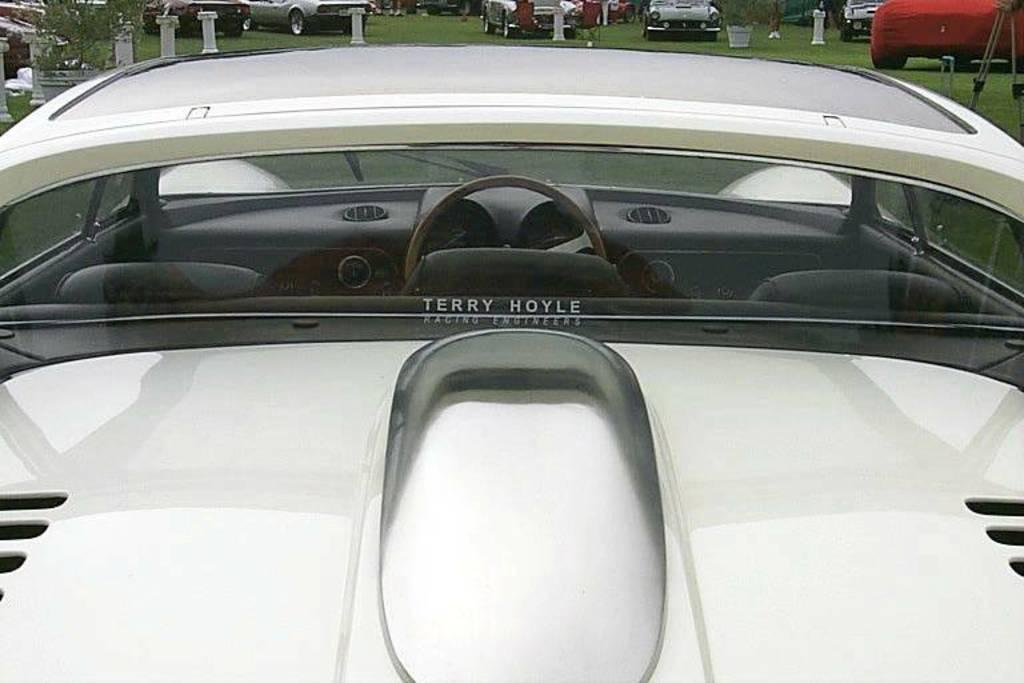What type of vehicle is in the image? There is a white car in the image. How much of the car can be seen in the image? The car appears to be partially visible or "truncated." What type of vegetation is present in the image? There is a plant and grass in the image. Are there any other vehicles in the image? Yes, there are other cars in the image. What type of stocking is the car wearing in the image? Cars do not wear stockings; the question is not applicable to the image. 